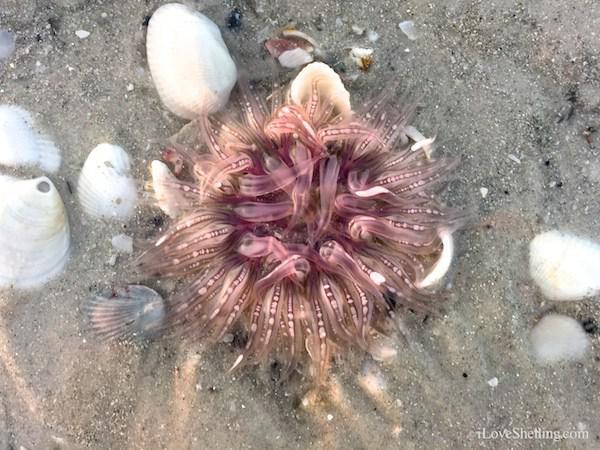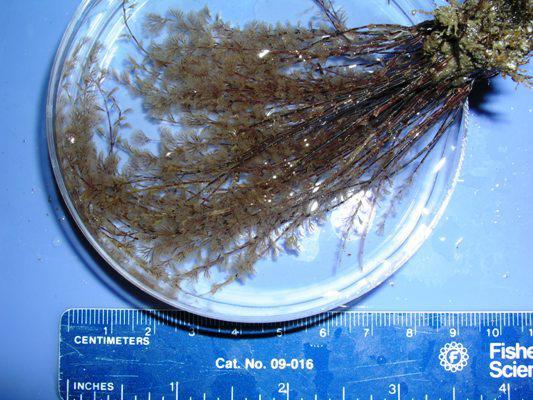The first image is the image on the left, the second image is the image on the right. Given the left and right images, does the statement "There is one ruler visible in the image." hold true? Answer yes or no. Yes. The first image is the image on the left, the second image is the image on the right. Examine the images to the left and right. Is the description "The right image shows a single prominent anemone with tendrils mostly spreading outward around a reddish-orange center." accurate? Answer yes or no. No. 